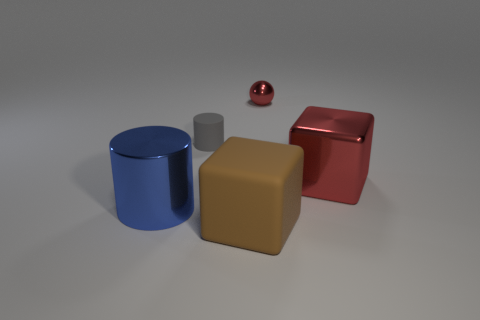Add 4 rubber blocks. How many objects exist? 9 Subtract all cylinders. How many objects are left? 3 Subtract all small shiny spheres. Subtract all yellow matte objects. How many objects are left? 4 Add 1 metal objects. How many metal objects are left? 4 Add 5 small gray objects. How many small gray objects exist? 6 Subtract 0 brown cylinders. How many objects are left? 5 